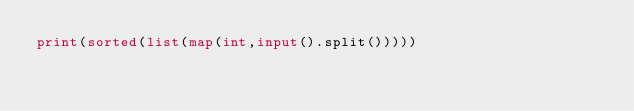<code> <loc_0><loc_0><loc_500><loc_500><_Python_>print(sorted(list(map(int,input().split()))))</code> 